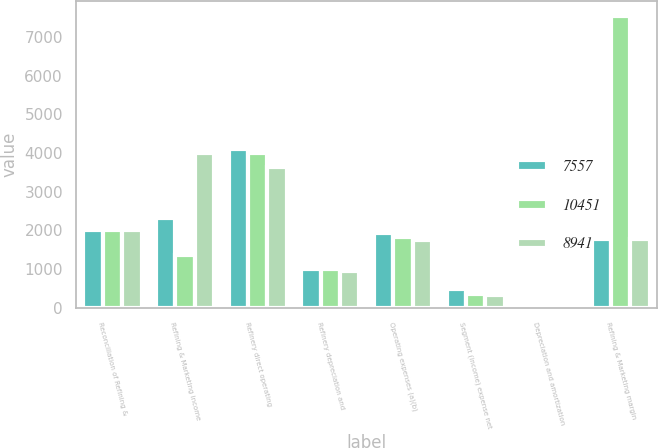<chart> <loc_0><loc_0><loc_500><loc_500><stacked_bar_chart><ecel><fcel>Reconciliation of Refining &<fcel>Refining & Marketing income<fcel>Refinery direct operating<fcel>Refinery depreciation and<fcel>Operating expenses (a)(b)<fcel>Segment (income) expense net<fcel>Depreciation and amortization<fcel>Refining & Marketing margin<nl><fcel>7557<fcel>2017<fcel>2321<fcel>4113<fcel>1013<fcel>1924<fcel>499<fcel>69<fcel>1788.5<nl><fcel>10451<fcel>2016<fcel>1357<fcel>4007<fcel>994<fcel>1835<fcel>360<fcel>69<fcel>7557<nl><fcel>8941<fcel>2015<fcel>3997<fcel>3640<fcel>955<fcel>1742<fcel>325<fcel>97<fcel>1788.5<nl></chart> 